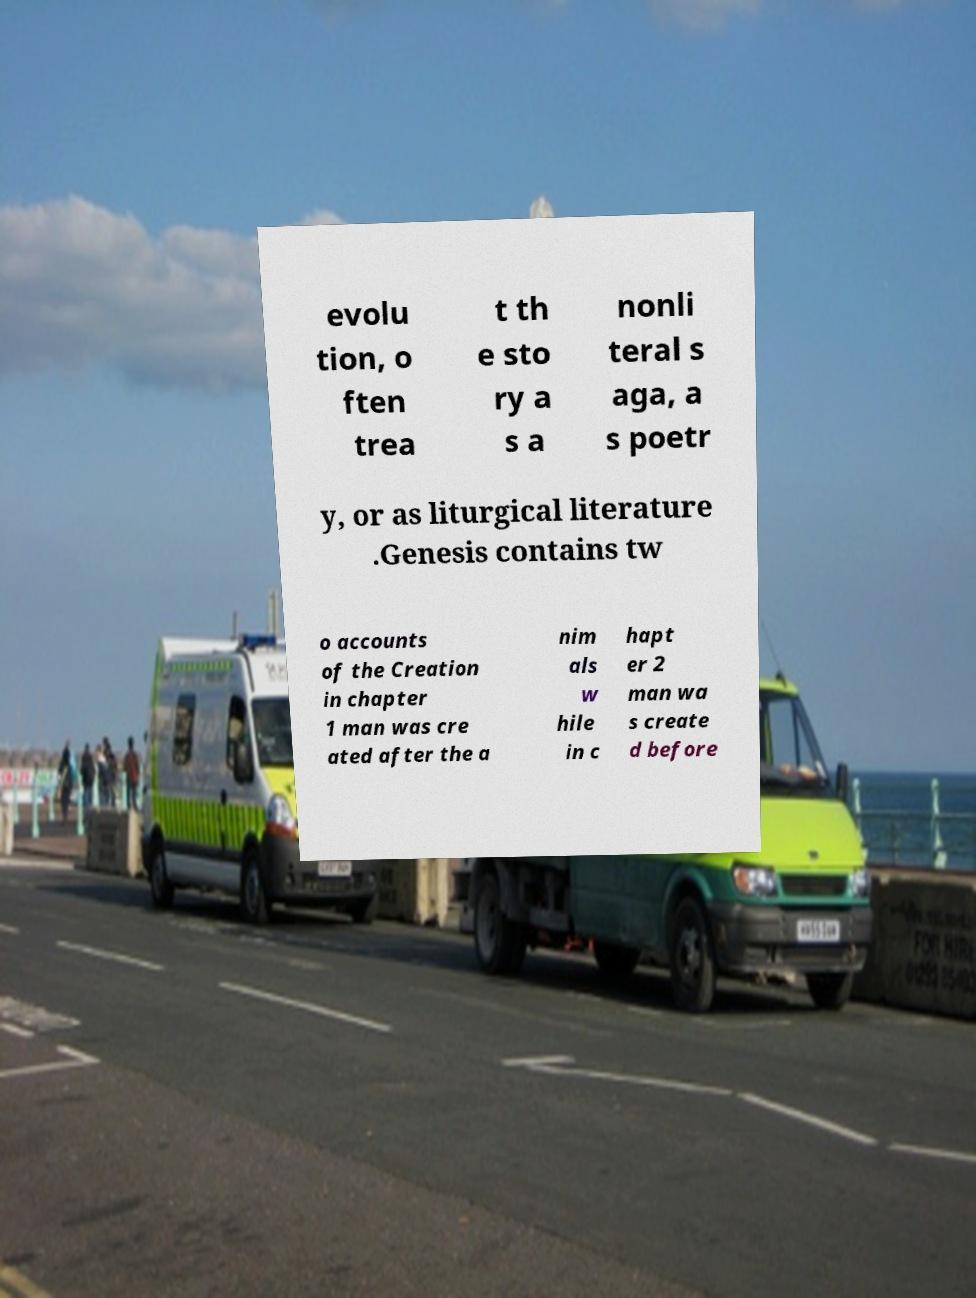Could you extract and type out the text from this image? evolu tion, o ften trea t th e sto ry a s a nonli teral s aga, a s poetr y, or as liturgical literature .Genesis contains tw o accounts of the Creation in chapter 1 man was cre ated after the a nim als w hile in c hapt er 2 man wa s create d before 